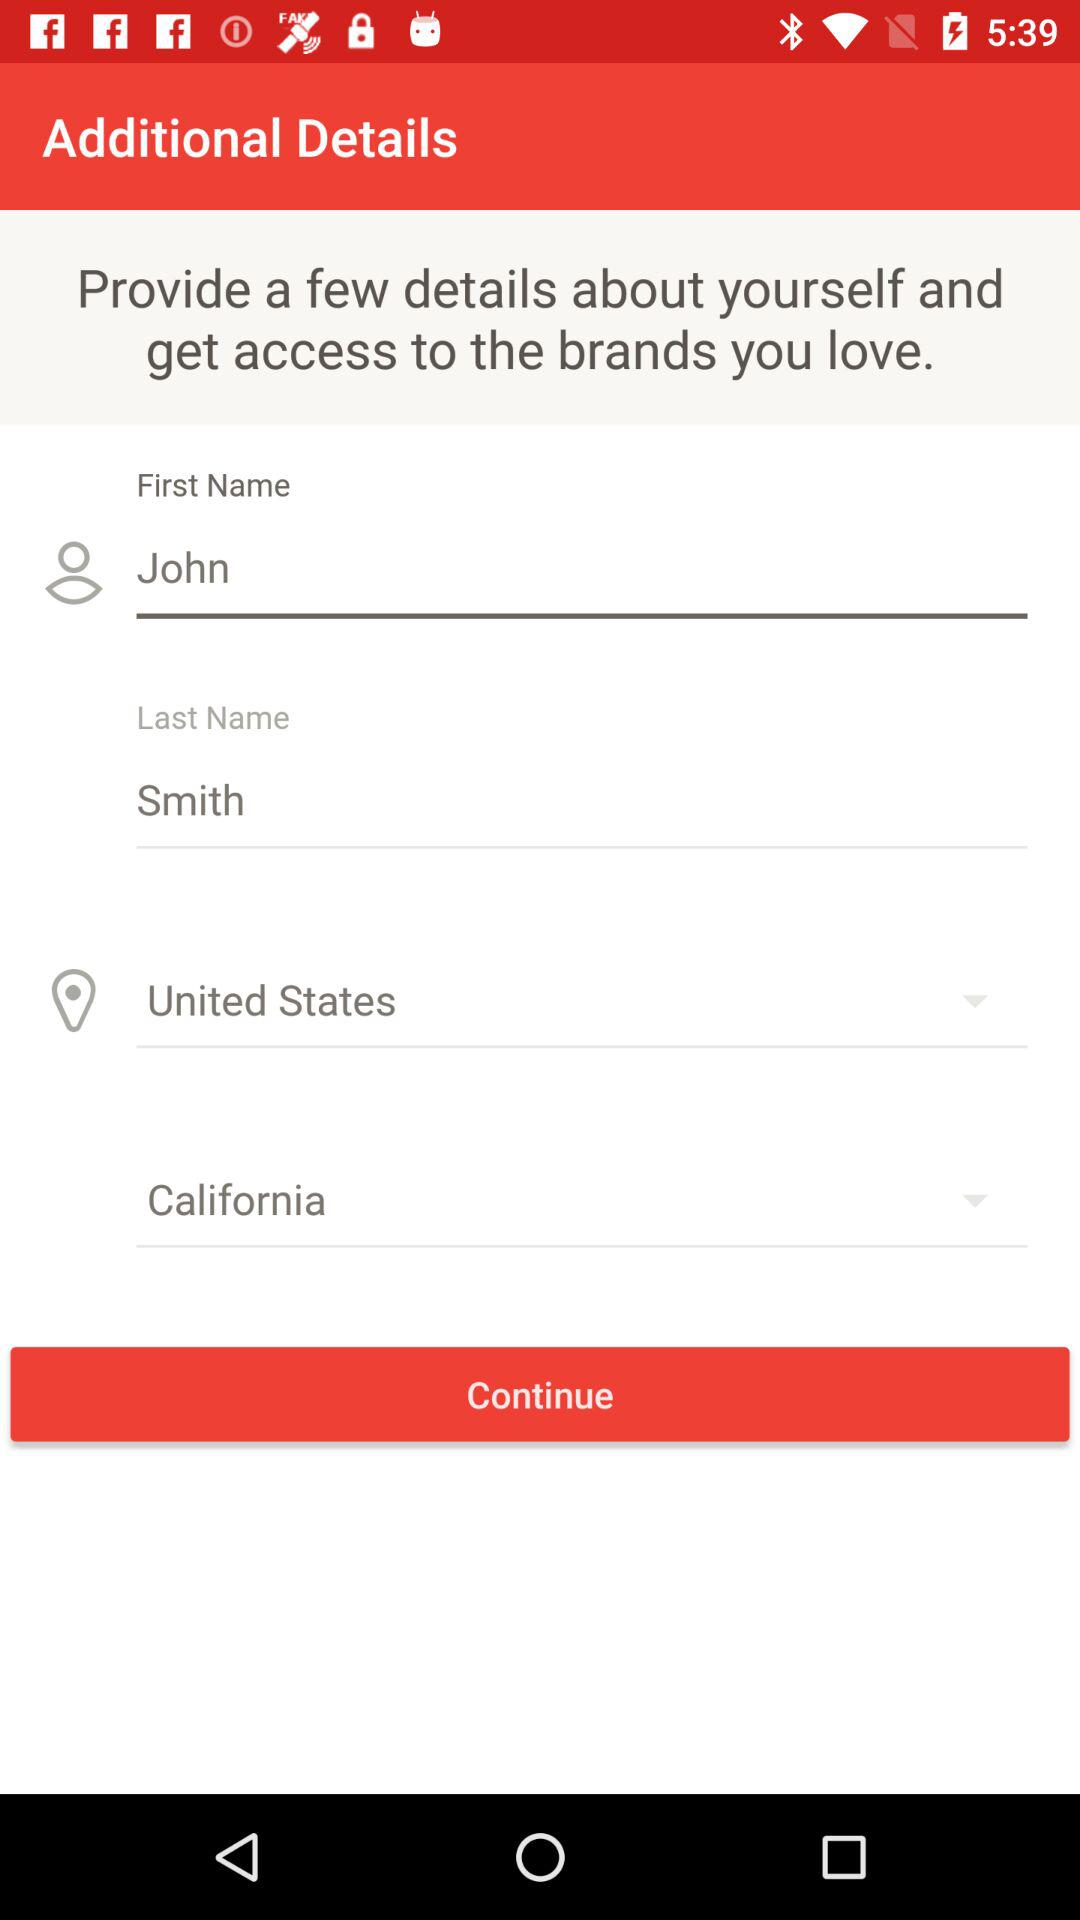What is the mentioned country? The mentioned country is the United States. 